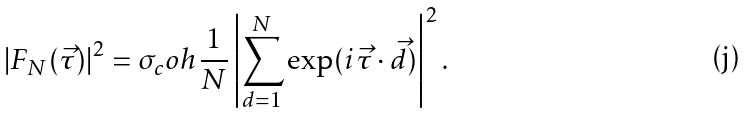Convert formula to latex. <formula><loc_0><loc_0><loc_500><loc_500>| F _ { N } ( \vec { \tau } ) | ^ { 2 } = \sigma _ { c } o h \, \frac { 1 } { N } \left | \sum _ { d = 1 } ^ { N } \exp ( i \vec { \tau } \cdot \vec { d } ) \right | ^ { 2 } .</formula> 